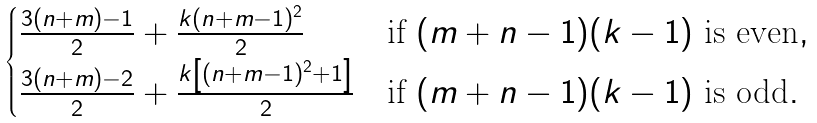Convert formula to latex. <formula><loc_0><loc_0><loc_500><loc_500>\begin{cases} \frac { 3 ( n + m ) - 1 } { 2 } + \frac { k ( n + m - 1 ) ^ { 2 } } { 2 } & \text {if } ( m + n - 1 ) ( k - 1 ) \text { is even} , \\ \frac { 3 ( n + m ) - 2 } { 2 } + \frac { k \left [ ( n + m - 1 ) ^ { 2 } + 1 \right ] } { 2 } & \text {if } ( m + n - 1 ) ( k - 1 ) \text { is odd} . \end{cases}</formula> 